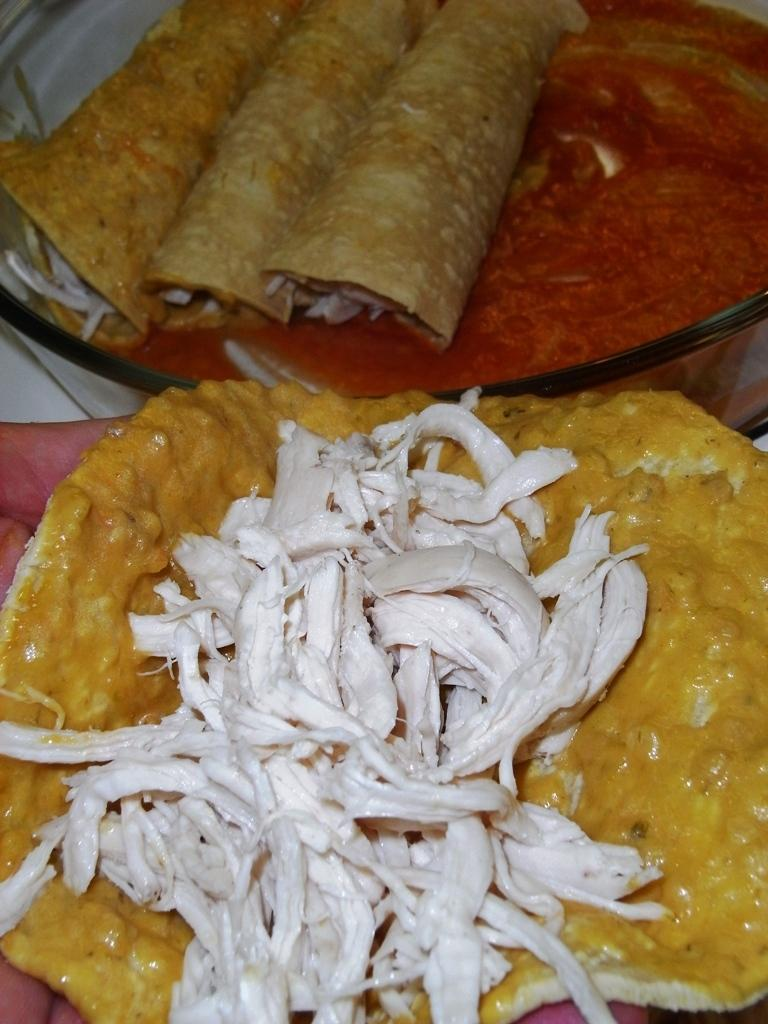What is in the bowl that is visible in the image? There are rolls in a bowl in the image. What else can be seen in the image besides the rolls? There is sauce in the image. What type of food item is on a tortilla in the image? There is another food item on a tortilla in the image. What type of shirt is being worn by the quarter in the image? There is no quarter or shirt present in the image. 